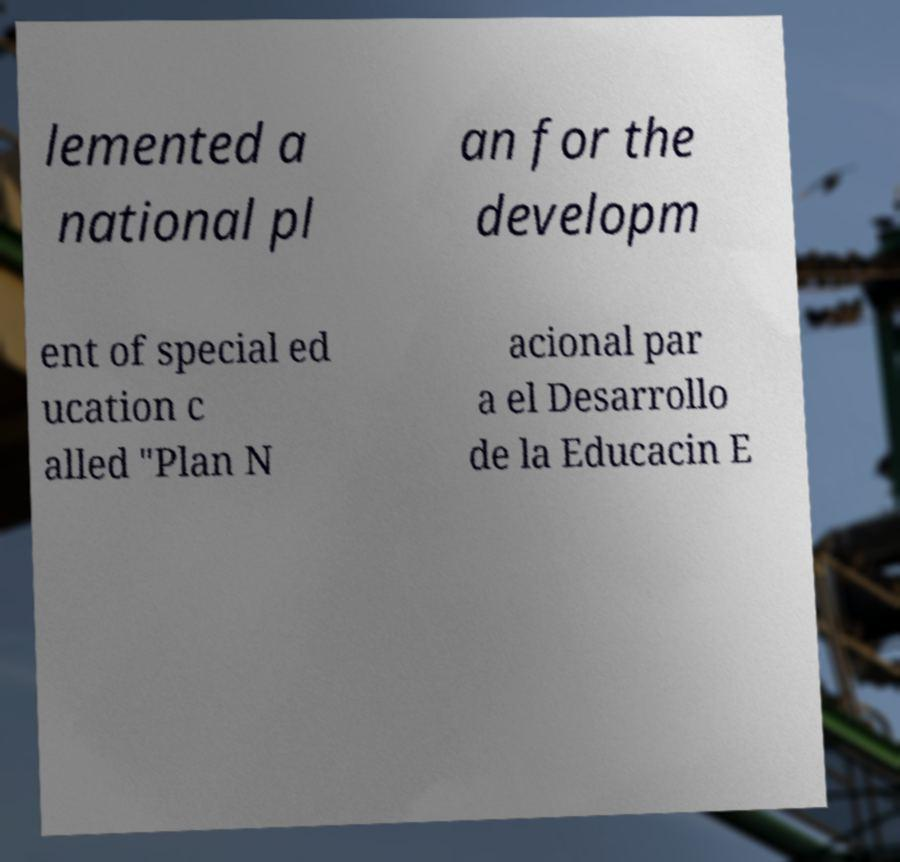Can you accurately transcribe the text from the provided image for me? lemented a national pl an for the developm ent of special ed ucation c alled "Plan N acional par a el Desarrollo de la Educacin E 